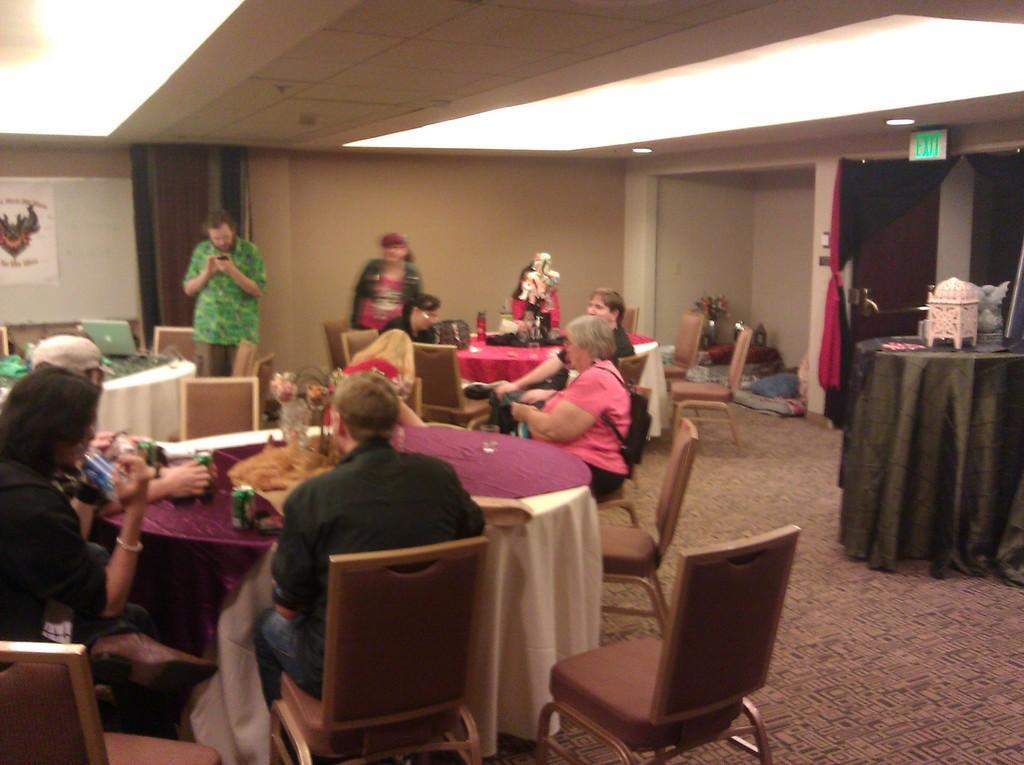Could you give a brief overview of what you see in this image? At the top we can see ceiling and lights. this is a exit board. This is a door. on the floor we can see few persons standing in front of a table and on the table we can see tins, flower vase, laptop. Few persons are sitting on chairs. This is a floor. 